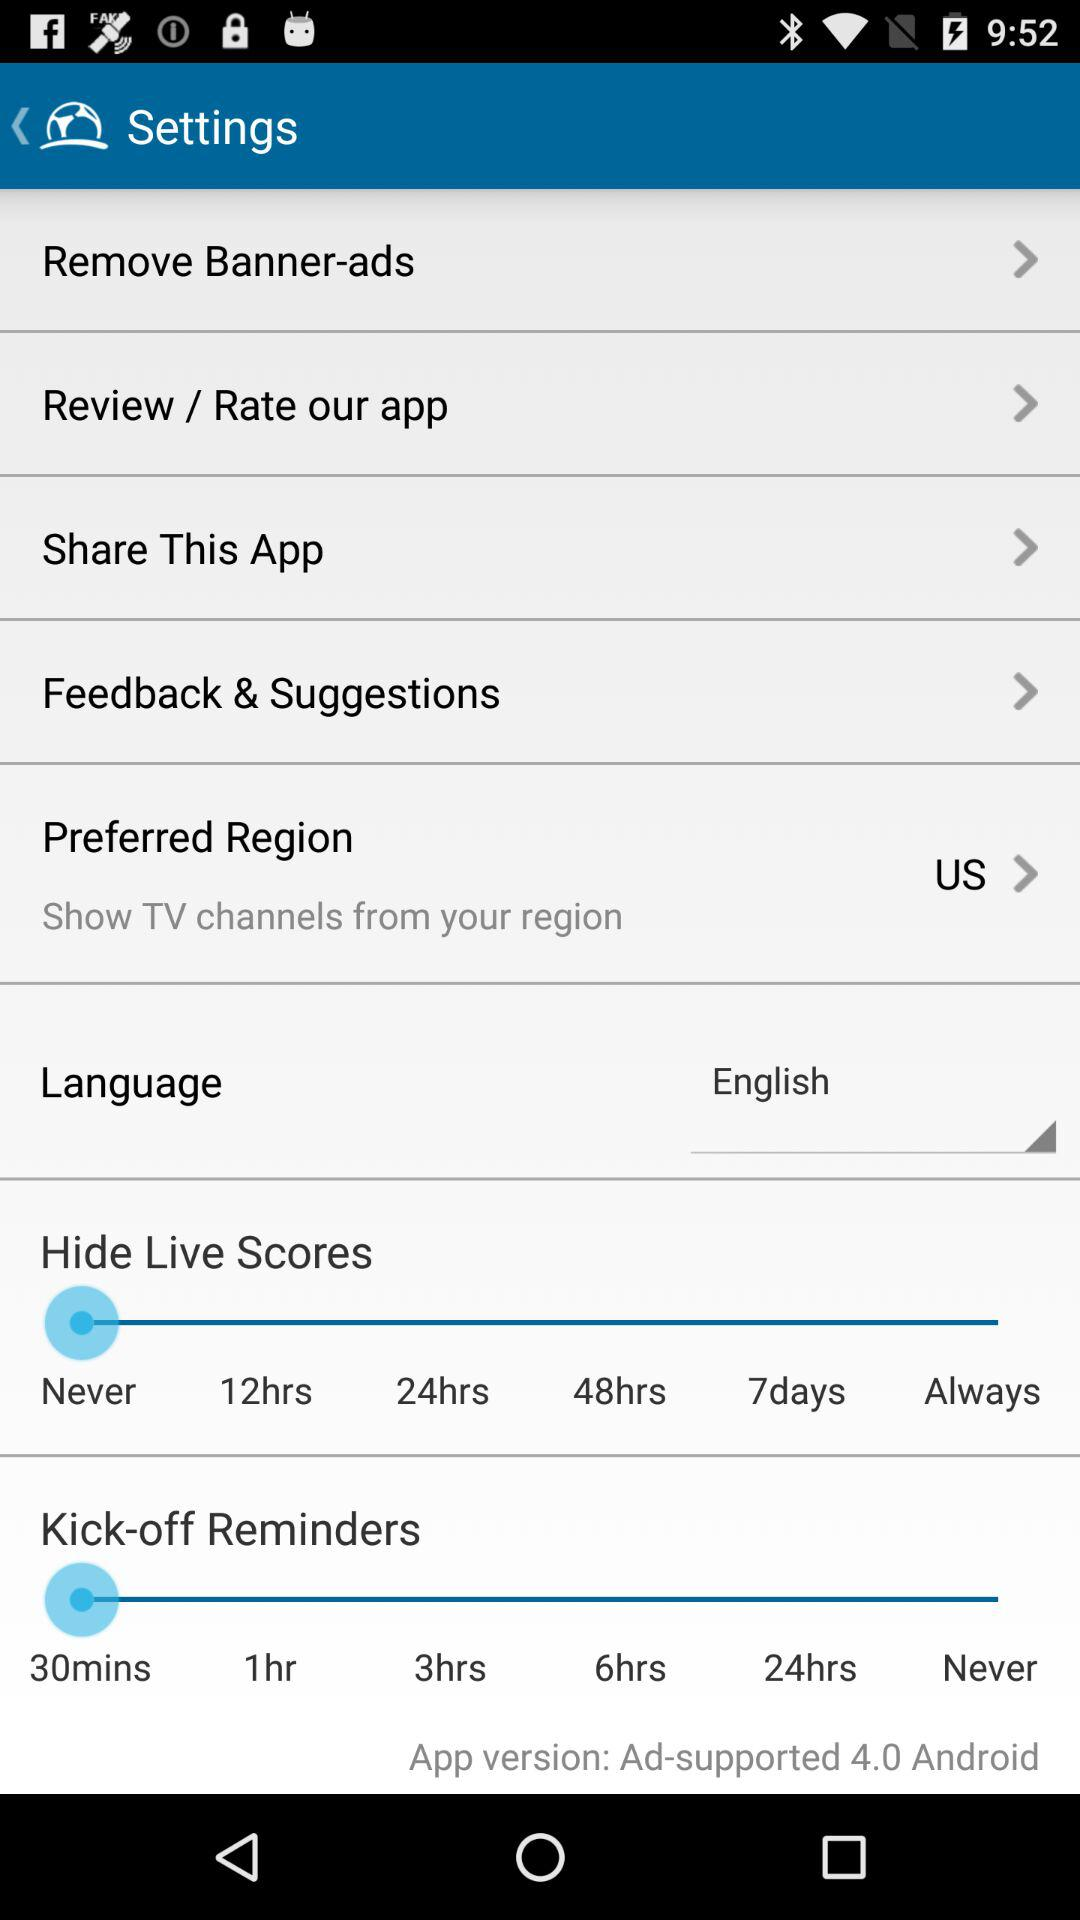What the preferred region? The preferred region is the US. 